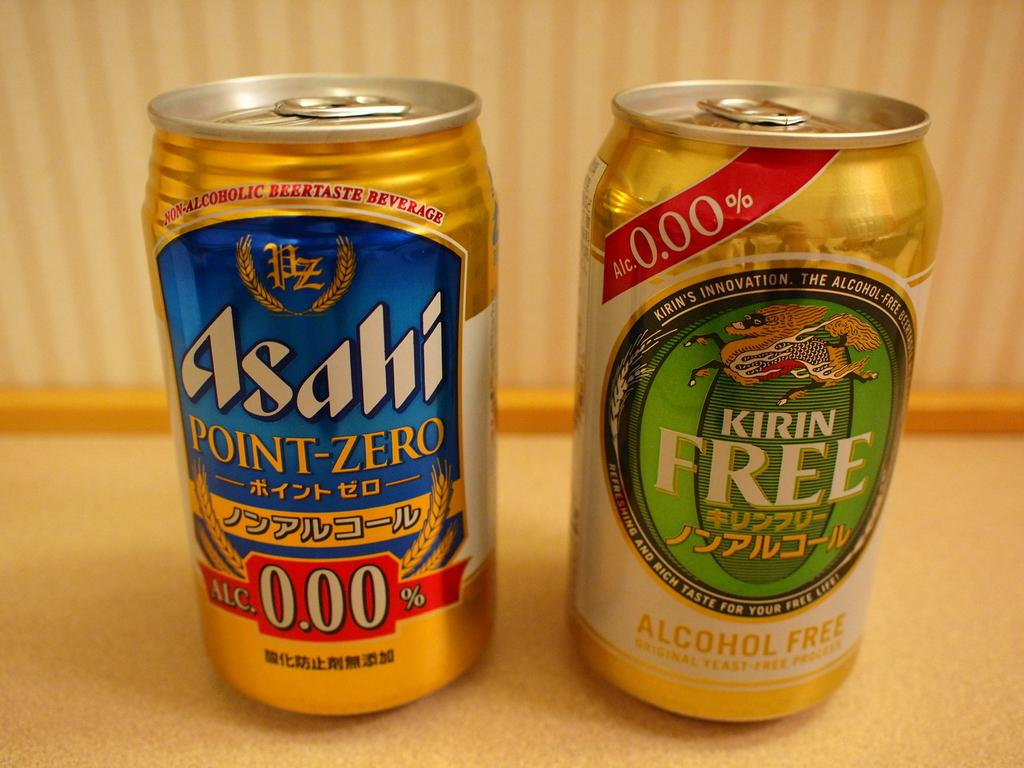Provide a one-sentence caption for the provided image. two gold aluminum cans of alcohol free beer. 